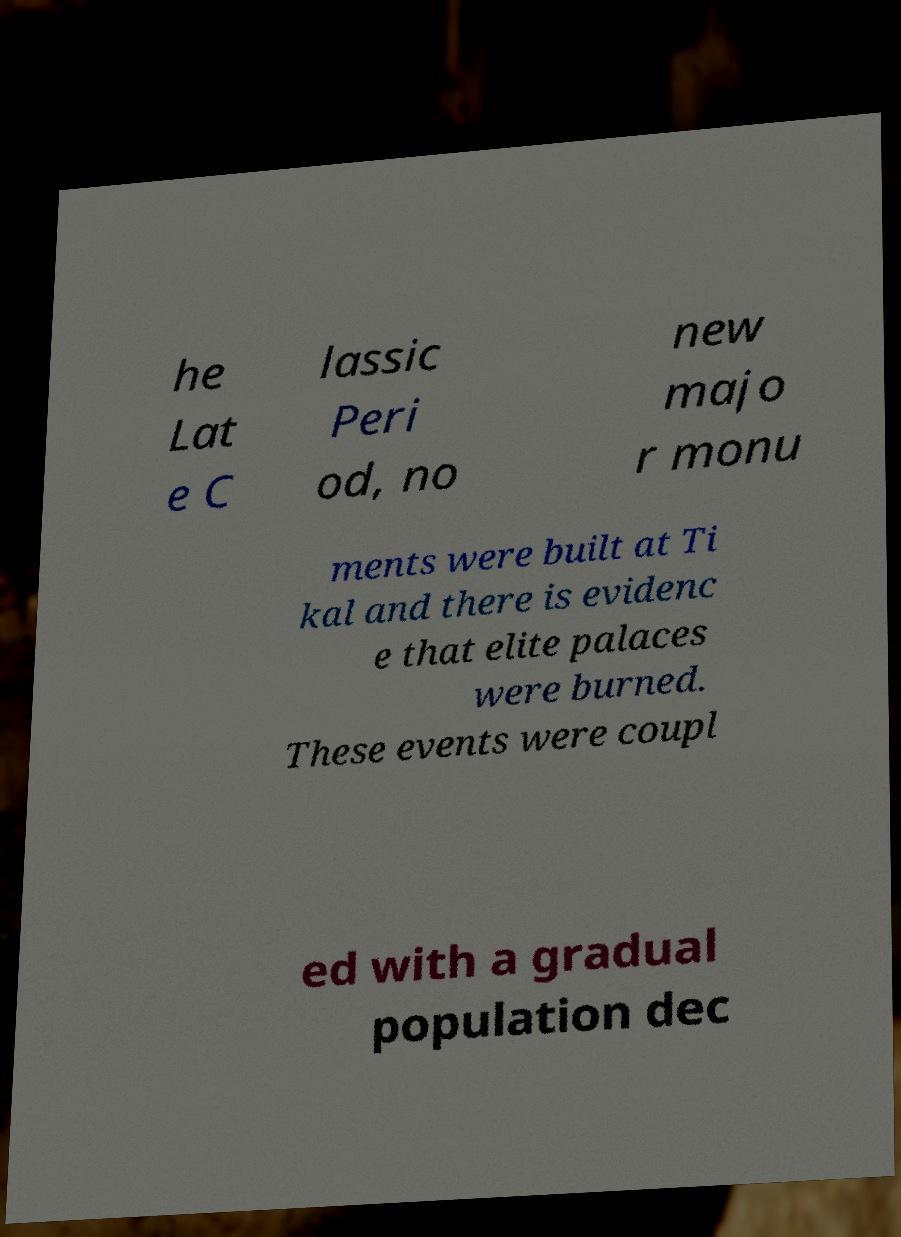Can you accurately transcribe the text from the provided image for me? he Lat e C lassic Peri od, no new majo r monu ments were built at Ti kal and there is evidenc e that elite palaces were burned. These events were coupl ed with a gradual population dec 